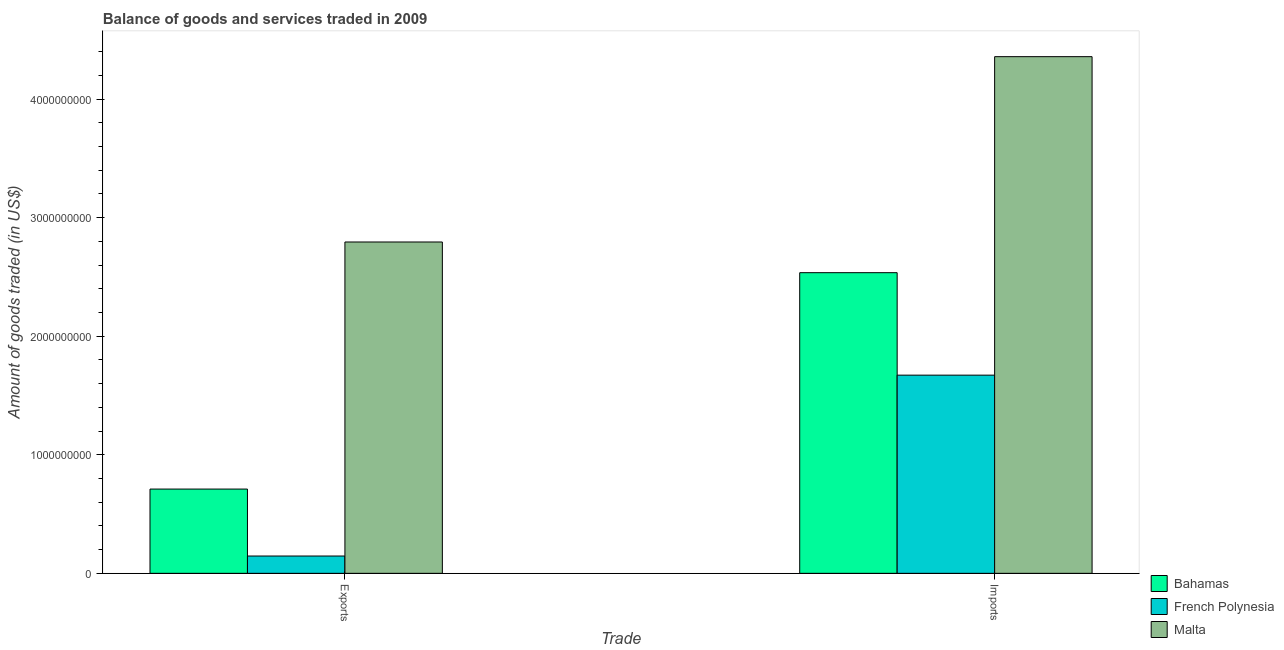How many different coloured bars are there?
Ensure brevity in your answer.  3. Are the number of bars on each tick of the X-axis equal?
Your answer should be very brief. Yes. How many bars are there on the 1st tick from the left?
Your response must be concise. 3. What is the label of the 1st group of bars from the left?
Offer a terse response. Exports. What is the amount of goods exported in French Polynesia?
Your answer should be compact. 1.46e+08. Across all countries, what is the maximum amount of goods exported?
Offer a terse response. 2.79e+09. Across all countries, what is the minimum amount of goods imported?
Offer a very short reply. 1.67e+09. In which country was the amount of goods imported maximum?
Provide a succinct answer. Malta. In which country was the amount of goods exported minimum?
Give a very brief answer. French Polynesia. What is the total amount of goods exported in the graph?
Your answer should be very brief. 3.65e+09. What is the difference between the amount of goods exported in Malta and that in Bahamas?
Your response must be concise. 2.08e+09. What is the difference between the amount of goods imported in Malta and the amount of goods exported in French Polynesia?
Ensure brevity in your answer.  4.21e+09. What is the average amount of goods imported per country?
Keep it short and to the point. 2.86e+09. What is the difference between the amount of goods exported and amount of goods imported in Malta?
Your response must be concise. -1.56e+09. In how many countries, is the amount of goods imported greater than 3400000000 US$?
Make the answer very short. 1. What is the ratio of the amount of goods imported in French Polynesia to that in Malta?
Provide a short and direct response. 0.38. What does the 1st bar from the left in Imports represents?
Make the answer very short. Bahamas. What does the 2nd bar from the right in Imports represents?
Offer a terse response. French Polynesia. What is the difference between two consecutive major ticks on the Y-axis?
Ensure brevity in your answer.  1.00e+09. Are the values on the major ticks of Y-axis written in scientific E-notation?
Your response must be concise. No. Does the graph contain any zero values?
Ensure brevity in your answer.  No. Does the graph contain grids?
Ensure brevity in your answer.  No. Where does the legend appear in the graph?
Your answer should be very brief. Bottom right. How many legend labels are there?
Offer a terse response. 3. How are the legend labels stacked?
Your response must be concise. Vertical. What is the title of the graph?
Your answer should be compact. Balance of goods and services traded in 2009. Does "Malta" appear as one of the legend labels in the graph?
Provide a short and direct response. Yes. What is the label or title of the X-axis?
Your answer should be very brief. Trade. What is the label or title of the Y-axis?
Your answer should be very brief. Amount of goods traded (in US$). What is the Amount of goods traded (in US$) in Bahamas in Exports?
Provide a succinct answer. 7.11e+08. What is the Amount of goods traded (in US$) of French Polynesia in Exports?
Keep it short and to the point. 1.46e+08. What is the Amount of goods traded (in US$) in Malta in Exports?
Give a very brief answer. 2.79e+09. What is the Amount of goods traded (in US$) in Bahamas in Imports?
Offer a very short reply. 2.54e+09. What is the Amount of goods traded (in US$) in French Polynesia in Imports?
Provide a short and direct response. 1.67e+09. What is the Amount of goods traded (in US$) of Malta in Imports?
Offer a very short reply. 4.36e+09. Across all Trade, what is the maximum Amount of goods traded (in US$) in Bahamas?
Ensure brevity in your answer.  2.54e+09. Across all Trade, what is the maximum Amount of goods traded (in US$) of French Polynesia?
Keep it short and to the point. 1.67e+09. Across all Trade, what is the maximum Amount of goods traded (in US$) in Malta?
Give a very brief answer. 4.36e+09. Across all Trade, what is the minimum Amount of goods traded (in US$) of Bahamas?
Provide a succinct answer. 7.11e+08. Across all Trade, what is the minimum Amount of goods traded (in US$) of French Polynesia?
Your response must be concise. 1.46e+08. Across all Trade, what is the minimum Amount of goods traded (in US$) of Malta?
Give a very brief answer. 2.79e+09. What is the total Amount of goods traded (in US$) in Bahamas in the graph?
Offer a terse response. 3.25e+09. What is the total Amount of goods traded (in US$) in French Polynesia in the graph?
Offer a very short reply. 1.82e+09. What is the total Amount of goods traded (in US$) of Malta in the graph?
Give a very brief answer. 7.15e+09. What is the difference between the Amount of goods traded (in US$) of Bahamas in Exports and that in Imports?
Give a very brief answer. -1.83e+09. What is the difference between the Amount of goods traded (in US$) of French Polynesia in Exports and that in Imports?
Ensure brevity in your answer.  -1.53e+09. What is the difference between the Amount of goods traded (in US$) of Malta in Exports and that in Imports?
Provide a short and direct response. -1.56e+09. What is the difference between the Amount of goods traded (in US$) in Bahamas in Exports and the Amount of goods traded (in US$) in French Polynesia in Imports?
Provide a succinct answer. -9.61e+08. What is the difference between the Amount of goods traded (in US$) of Bahamas in Exports and the Amount of goods traded (in US$) of Malta in Imports?
Make the answer very short. -3.65e+09. What is the difference between the Amount of goods traded (in US$) in French Polynesia in Exports and the Amount of goods traded (in US$) in Malta in Imports?
Offer a terse response. -4.21e+09. What is the average Amount of goods traded (in US$) in Bahamas per Trade?
Your answer should be very brief. 1.62e+09. What is the average Amount of goods traded (in US$) in French Polynesia per Trade?
Provide a succinct answer. 9.09e+08. What is the average Amount of goods traded (in US$) in Malta per Trade?
Provide a succinct answer. 3.58e+09. What is the difference between the Amount of goods traded (in US$) of Bahamas and Amount of goods traded (in US$) of French Polynesia in Exports?
Make the answer very short. 5.65e+08. What is the difference between the Amount of goods traded (in US$) of Bahamas and Amount of goods traded (in US$) of Malta in Exports?
Your answer should be compact. -2.08e+09. What is the difference between the Amount of goods traded (in US$) in French Polynesia and Amount of goods traded (in US$) in Malta in Exports?
Make the answer very short. -2.65e+09. What is the difference between the Amount of goods traded (in US$) in Bahamas and Amount of goods traded (in US$) in French Polynesia in Imports?
Your answer should be compact. 8.64e+08. What is the difference between the Amount of goods traded (in US$) of Bahamas and Amount of goods traded (in US$) of Malta in Imports?
Ensure brevity in your answer.  -1.82e+09. What is the difference between the Amount of goods traded (in US$) in French Polynesia and Amount of goods traded (in US$) in Malta in Imports?
Your response must be concise. -2.69e+09. What is the ratio of the Amount of goods traded (in US$) of Bahamas in Exports to that in Imports?
Keep it short and to the point. 0.28. What is the ratio of the Amount of goods traded (in US$) of French Polynesia in Exports to that in Imports?
Keep it short and to the point. 0.09. What is the ratio of the Amount of goods traded (in US$) in Malta in Exports to that in Imports?
Give a very brief answer. 0.64. What is the difference between the highest and the second highest Amount of goods traded (in US$) of Bahamas?
Your answer should be compact. 1.83e+09. What is the difference between the highest and the second highest Amount of goods traded (in US$) in French Polynesia?
Your answer should be very brief. 1.53e+09. What is the difference between the highest and the second highest Amount of goods traded (in US$) of Malta?
Your answer should be compact. 1.56e+09. What is the difference between the highest and the lowest Amount of goods traded (in US$) of Bahamas?
Give a very brief answer. 1.83e+09. What is the difference between the highest and the lowest Amount of goods traded (in US$) in French Polynesia?
Give a very brief answer. 1.53e+09. What is the difference between the highest and the lowest Amount of goods traded (in US$) of Malta?
Provide a succinct answer. 1.56e+09. 